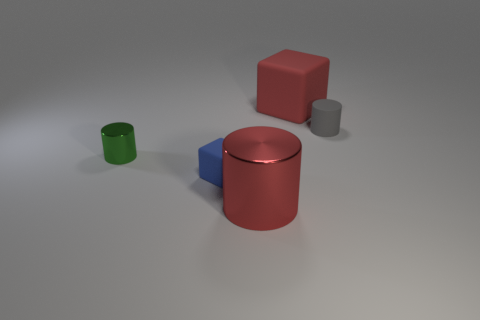There is a gray rubber thing to the right of the big matte block; does it have the same shape as the big red object behind the tiny gray rubber cylinder?
Offer a very short reply. No. How many things are either big cyan matte things or big things?
Your answer should be compact. 2. What size is the green thing that is the same shape as the small gray object?
Offer a terse response. Small. Is the number of cylinders that are right of the green cylinder greater than the number of big brown rubber cubes?
Provide a short and direct response. Yes. Are the red block and the blue block made of the same material?
Ensure brevity in your answer.  Yes. How many objects are either big things that are behind the tiny shiny cylinder or large red objects behind the small green thing?
Keep it short and to the point. 1. The other big thing that is the same shape as the blue rubber thing is what color?
Your answer should be compact. Red. How many cylinders have the same color as the big matte thing?
Your answer should be very brief. 1. Does the small metallic object have the same color as the big matte object?
Your answer should be very brief. No. How many objects are small objects that are behind the tiny cube or shiny cylinders?
Offer a very short reply. 3. 